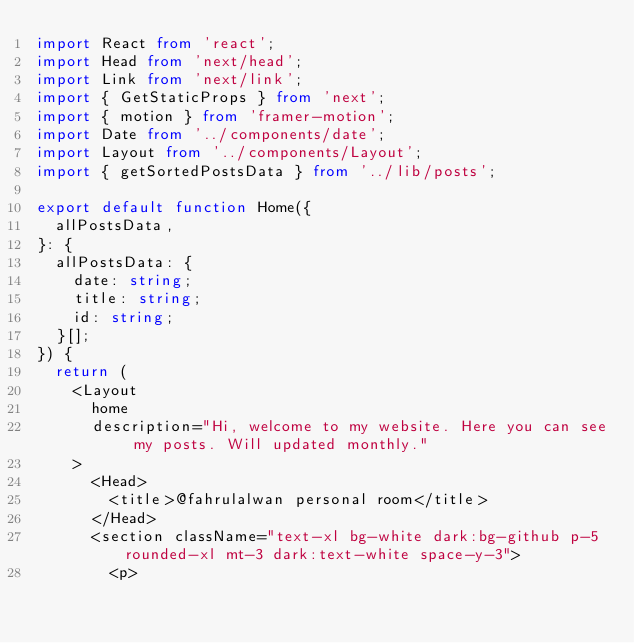Convert code to text. <code><loc_0><loc_0><loc_500><loc_500><_TypeScript_>import React from 'react';
import Head from 'next/head';
import Link from 'next/link';
import { GetStaticProps } from 'next';
import { motion } from 'framer-motion';
import Date from '../components/date';
import Layout from '../components/Layout';
import { getSortedPostsData } from '../lib/posts';

export default function Home({
  allPostsData,
}: {
  allPostsData: {
    date: string;
    title: string;
    id: string;
  }[];
}) {
  return (
    <Layout
      home
      description="Hi, welcome to my website. Here you can see my posts. Will updated monthly."
    >
      <Head>
        <title>@fahrulalwan personal room</title>
      </Head>
      <section className="text-xl bg-white dark:bg-github p-5 rounded-xl mt-3 dark:text-white space-y-3">
        <p></code> 